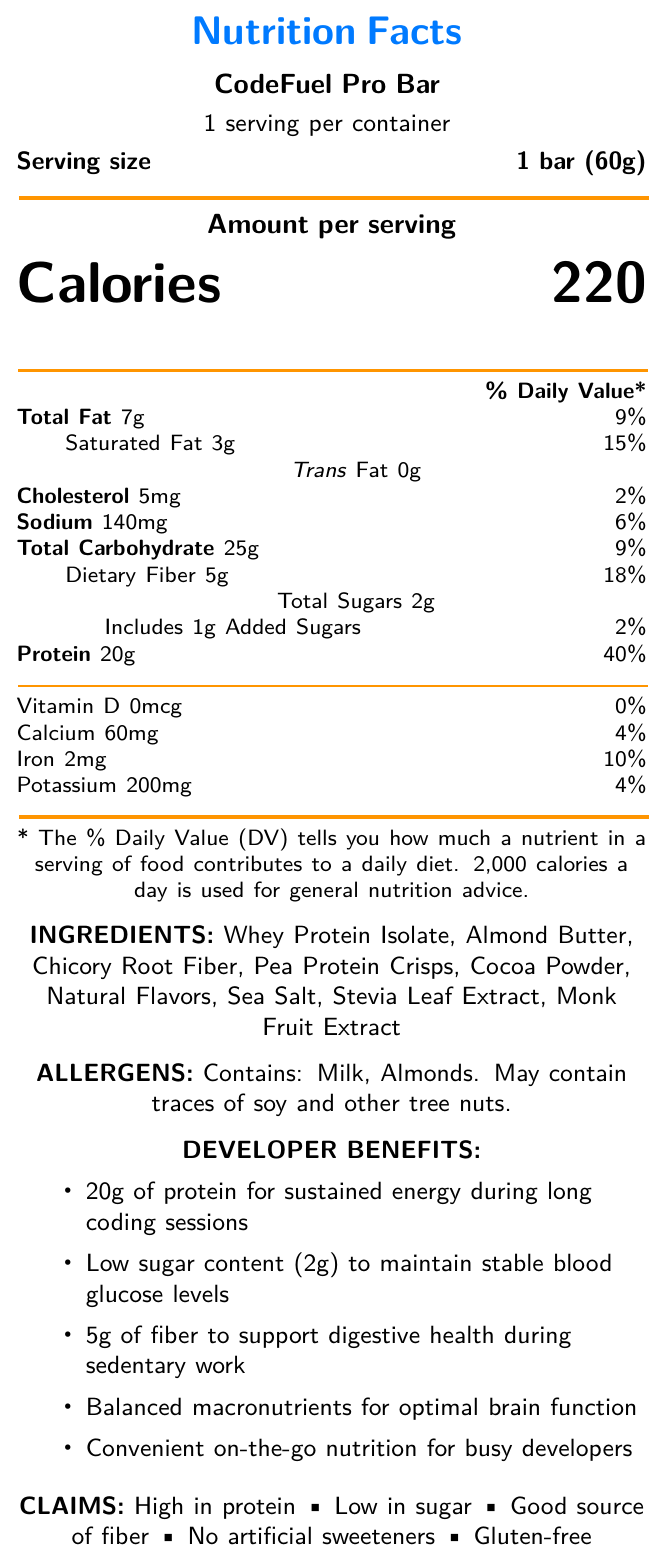what is the serving size? The serving size is explicitly mentioned as "1 bar (60g)" in the document.
Answer: 1 bar (60g) how many calories are in one serving? The document shows "Calories 220" which indicates the amount of calories per serving.
Answer: 220 what is the total fat content in one bar? The document indicates "Total Fat 7g" per serving.
Answer: 7g what ingredients are used in the CodeFuel Pro Bar? The list of ingredients is shown under the "INGREDIENTS" section.
Answer: Whey Protein Isolate, Almond Butter, Chicory Root Fiber, Pea Protein Crisps, Cocoa Powder, Natural Flavors, Sea Salt, Stevia Leaf Extract, Monk Fruit Extract what is the main benefit of consuming 20g of protein for developers? The document mentions "20g of protein for sustained energy during long coding sessions" under the "DEVELOPER BENEFITS" section.
Answer: Sustained energy during long coding sessions what percentage of the daily value of protein does one bar provide? The document indicates "Protein 20g 40%" which is the daily value percentage for protein content.
Answer: 40% are there any added sugars in the CodeFuel Pro Bar? The document indicates "Includes 1g Added Sugars" suggesting the presence of added sugars.
Answer: Yes what allergens are present in the CodeFuel Pro Bar? A. Peanuts and Soy B. Milk and Almonds C. Wheat and Soy D. Milk and Peanuts The document mentions "Contains: Milk, Almonds. May contain traces of soy and other tree nuts" under the "ALLERGENS" section.
Answer: B what is the primary source of protein in the CodeFuel Pro Bar? A. Pea Protein Crisps B. Whey Protein Isolate C. Almond Butter D. Chicory Root Fiber The first ingredient listed is "Whey Protein Isolate," indicating it is the primary source of protein.
Answer: B is the CodeFuel Pro Bar gluten-free? The claim of "Gluten-free" is explicitly mentioned under the "CLAIMS" section.
Answer: Yes does the CodeFuel Pro Bar contain any artificial sweeteners? The document states "No artificial sweeteners" under the "CLAIMS" section.
Answer: No summarize the nutritional content and benefits of the CodeFuel Pro Bar. This summary captures the key nutritional values, claim statements, and the specific benefits for developers as mentioned in the document.
Answer: The CodeFuel Pro Bar contains 220 calories per bar, with 7g of total fat, 3g of saturated fat, 0g of trans fat, 5mg of cholesterol, 140mg of sodium, 25g of total carbohydrates, 5g of dietary fiber, 2g of total sugars including 1g of added sugars, and 20g of protein. It also contains calcium, iron, and potassium. The bar is designed to provide high protein, low sugar, and good fiber content, making it suitable for developers needing sustained energy, stable blood glucose, and digestive health support. It is also gluten-free and contains no artificial sweeteners. what is the ratio of dietary fiber to total carbohydrates in one serving? The document shows 5g of dietary fiber and 25g of total carbohydrates. Thus, the ratio is 5g:25g, which simplifies to 1:5.
Answer: 1:5 what is the percentage daily value of saturated fat in one bar? The document shows "Saturated Fat 3g 15%" indicating the percent daily value.
Answer: 15% what benefit does the fiber content offer to developers? The developer benefits section mentions "5g of fiber to support digestive health during sedentary work".
Answer: Supports digestive health during sedentary work does the nutrition label specify the amount of Vitamin C in the CodeFuel Pro Bar? The document does not mention Vitamin C in the nutritional content section.
Answer: No what is the role of 'Monk Fruit Extract' in the ingredients list? The document lists 'Monk Fruit Extract' as an ingredient but does not specify its role or function.
Answer: Not enough information 